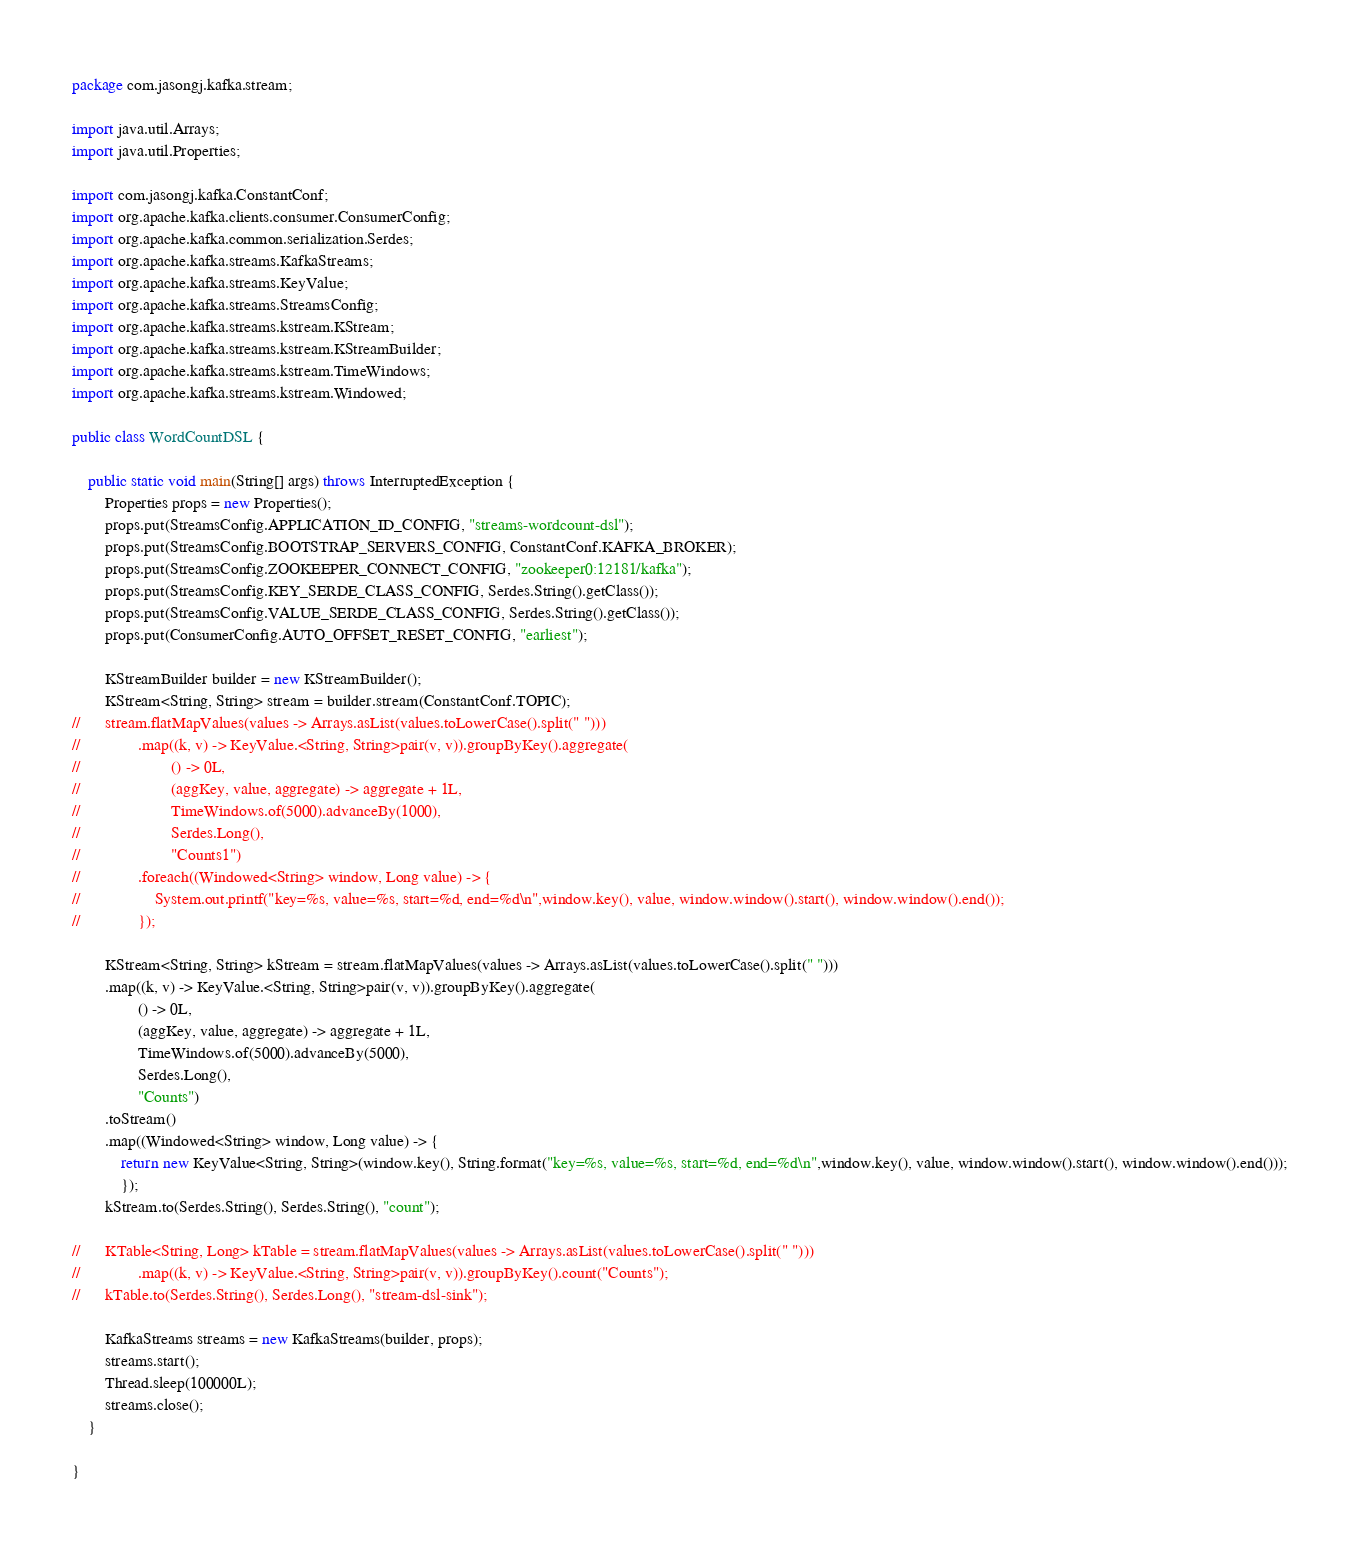<code> <loc_0><loc_0><loc_500><loc_500><_Java_>package com.jasongj.kafka.stream;

import java.util.Arrays;
import java.util.Properties;

import com.jasongj.kafka.ConstantConf;
import org.apache.kafka.clients.consumer.ConsumerConfig;
import org.apache.kafka.common.serialization.Serdes;
import org.apache.kafka.streams.KafkaStreams;
import org.apache.kafka.streams.KeyValue;
import org.apache.kafka.streams.StreamsConfig;
import org.apache.kafka.streams.kstream.KStream;
import org.apache.kafka.streams.kstream.KStreamBuilder;
import org.apache.kafka.streams.kstream.TimeWindows;
import org.apache.kafka.streams.kstream.Windowed;

public class WordCountDSL {

	public static void main(String[] args) throws InterruptedException {
		Properties props = new Properties();
		props.put(StreamsConfig.APPLICATION_ID_CONFIG, "streams-wordcount-dsl");
		props.put(StreamsConfig.BOOTSTRAP_SERVERS_CONFIG, ConstantConf.KAFKA_BROKER);
		props.put(StreamsConfig.ZOOKEEPER_CONNECT_CONFIG, "zookeeper0:12181/kafka");
		props.put(StreamsConfig.KEY_SERDE_CLASS_CONFIG, Serdes.String().getClass());
		props.put(StreamsConfig.VALUE_SERDE_CLASS_CONFIG, Serdes.String().getClass());
		props.put(ConsumerConfig.AUTO_OFFSET_RESET_CONFIG, "earliest");

		KStreamBuilder builder = new KStreamBuilder();
		KStream<String, String> stream = builder.stream(ConstantConf.TOPIC);
//		stream.flatMapValues(values -> Arrays.asList(values.toLowerCase().split(" ")))
//				.map((k, v) -> KeyValue.<String, String>pair(v, v)).groupByKey().aggregate(
//						() -> 0L,
//						(aggKey, value, aggregate) -> aggregate + 1L, 
//						TimeWindows.of(5000).advanceBy(1000),
//						Serdes.Long(), 
//						"Counts1")
//				.foreach((Windowed<String> window, Long value) -> {
//					System.out.printf("key=%s, value=%s, start=%d, end=%d\n",window.key(), value, window.window().start(), window.window().end());
//				});
		
		KStream<String, String> kStream = stream.flatMapValues(values -> Arrays.asList(values.toLowerCase().split(" ")))
		.map((k, v) -> KeyValue.<String, String>pair(v, v)).groupByKey().aggregate(
				() -> 0L,
				(aggKey, value, aggregate) -> aggregate + 1L, 
				TimeWindows.of(5000).advanceBy(5000),
				Serdes.Long(), 
				"Counts")
		.toStream()
		.map((Windowed<String> window, Long value) -> {
			return new KeyValue<String, String>(window.key(), String.format("key=%s, value=%s, start=%d, end=%d\n",window.key(), value, window.window().start(), window.window().end()));
			});
		kStream.to(Serdes.String(), Serdes.String(), "count");
		
//		KTable<String, Long> kTable = stream.flatMapValues(values -> Arrays.asList(values.toLowerCase().split(" ")))
//				.map((k, v) -> KeyValue.<String, String>pair(v, v)).groupByKey().count("Counts");
//		kTable.to(Serdes.String(), Serdes.Long(), "stream-dsl-sink");

		KafkaStreams streams = new KafkaStreams(builder, props);
		streams.start();
		Thread.sleep(100000L);
		streams.close();
	}

}
</code> 